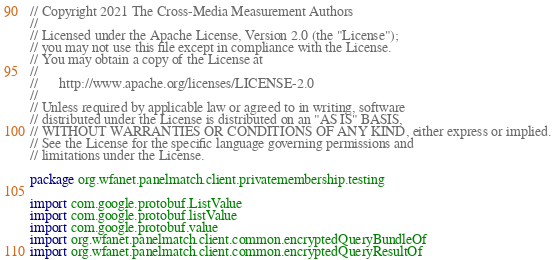Convert code to text. <code><loc_0><loc_0><loc_500><loc_500><_Kotlin_>// Copyright 2021 The Cross-Media Measurement Authors
//
// Licensed under the Apache License, Version 2.0 (the "License");
// you may not use this file except in compliance with the License.
// You may obtain a copy of the License at
//
//      http://www.apache.org/licenses/LICENSE-2.0
//
// Unless required by applicable law or agreed to in writing, software
// distributed under the License is distributed on an "AS IS" BASIS,
// WITHOUT WARRANTIES OR CONDITIONS OF ANY KIND, either express or implied.
// See the License for the specific language governing permissions and
// limitations under the License.

package org.wfanet.panelmatch.client.privatemembership.testing

import com.google.protobuf.ListValue
import com.google.protobuf.listValue
import com.google.protobuf.value
import org.wfanet.panelmatch.client.common.encryptedQueryBundleOf
import org.wfanet.panelmatch.client.common.encryptedQueryResultOf</code> 